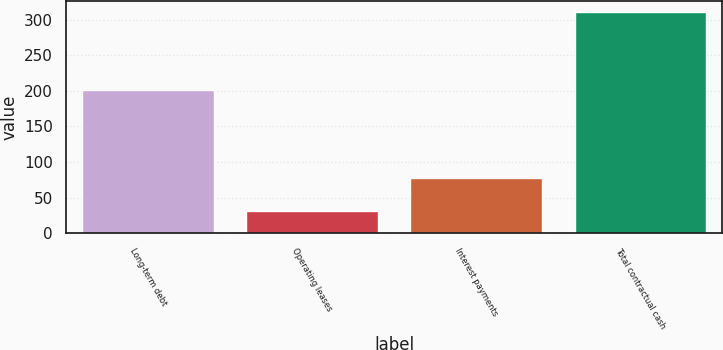<chart> <loc_0><loc_0><loc_500><loc_500><bar_chart><fcel>Long-term debt<fcel>Operating leases<fcel>Interest payments<fcel>Total contractual cash<nl><fcel>201.3<fcel>31.5<fcel>78.1<fcel>310.9<nl></chart> 